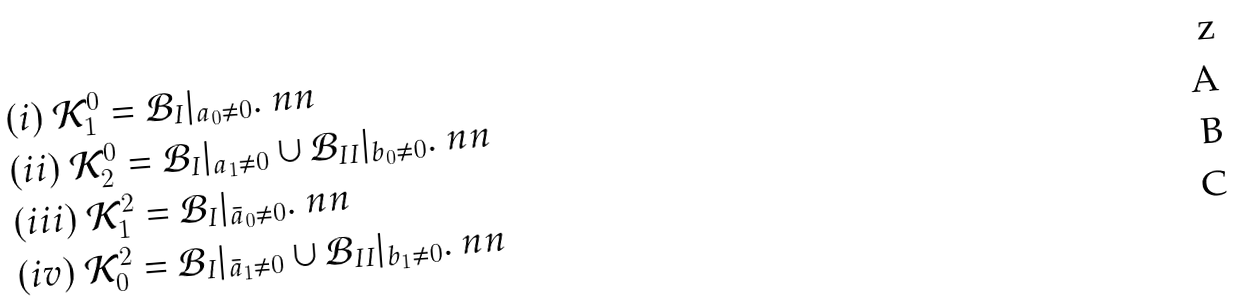Convert formula to latex. <formula><loc_0><loc_0><loc_500><loc_500>& ( i ) \ \mathcal { K } _ { 1 } ^ { 0 } = \mathcal { B } _ { I } | _ { a _ { 0 } \neq 0 } . \ n n \\ & ( i i ) \ \mathcal { K } _ { 2 } ^ { 0 } = \mathcal { B } _ { I } | _ { a _ { 1 } \neq 0 } \cup \mathcal { B } _ { I I } | _ { b _ { 0 } \neq 0 } . \ n n \\ & ( i i i ) \ \mathcal { K } _ { 1 } ^ { 2 } = \mathcal { B } _ { I } | _ { \bar { a } _ { 0 } \neq 0 } . \ n n \\ & ( i v ) \ \mathcal { K } _ { 0 } ^ { 2 } = \mathcal { B } _ { I } | _ { \bar { a } _ { 1 } \neq 0 } \cup \mathcal { B } _ { I I } | _ { b _ { 1 } \neq 0 } . \ n n</formula> 